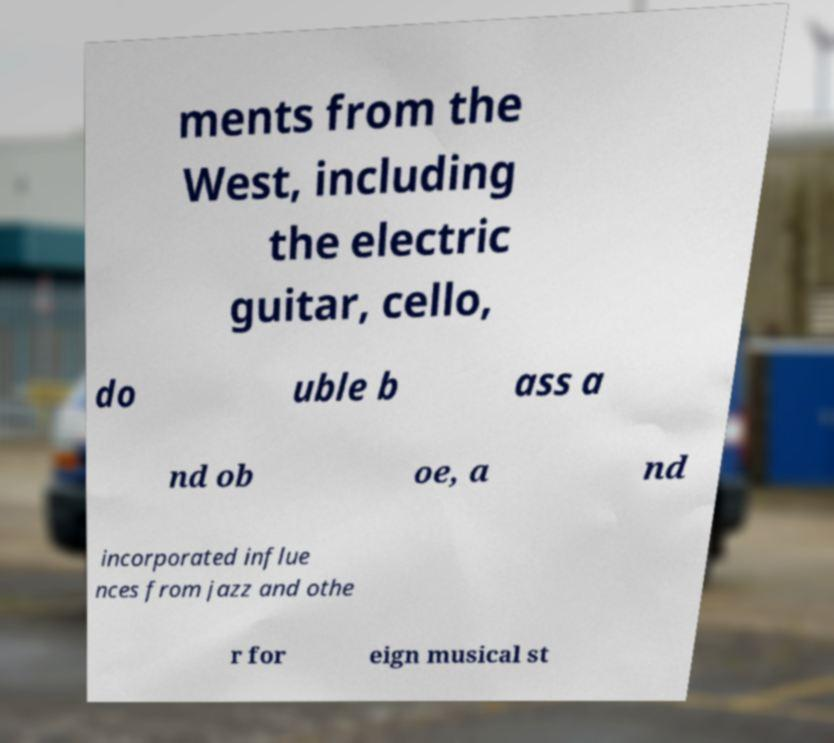Please identify and transcribe the text found in this image. ments from the West, including the electric guitar, cello, do uble b ass a nd ob oe, a nd incorporated influe nces from jazz and othe r for eign musical st 